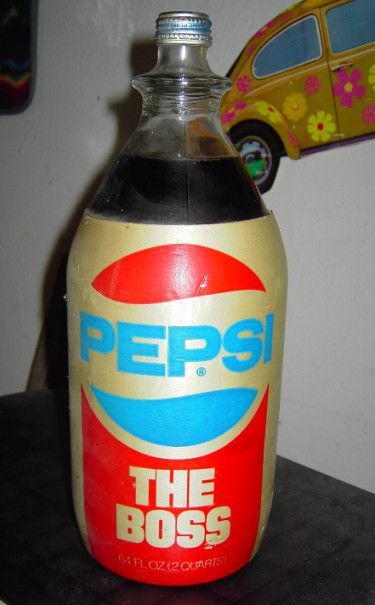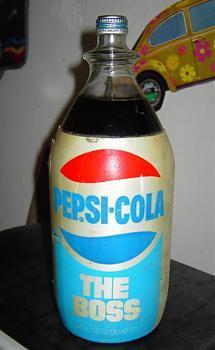The first image is the image on the left, the second image is the image on the right. Analyze the images presented: Is the assertion "The left and right images each feature a single soda bottle with its cap on, and the bottles on the left and right contain the same amount of soda and have similar but not identical labels." valid? Answer yes or no. Yes. The first image is the image on the left, the second image is the image on the right. Assess this claim about the two images: "Pepsi brand is present.". Correct or not? Answer yes or no. Yes. 